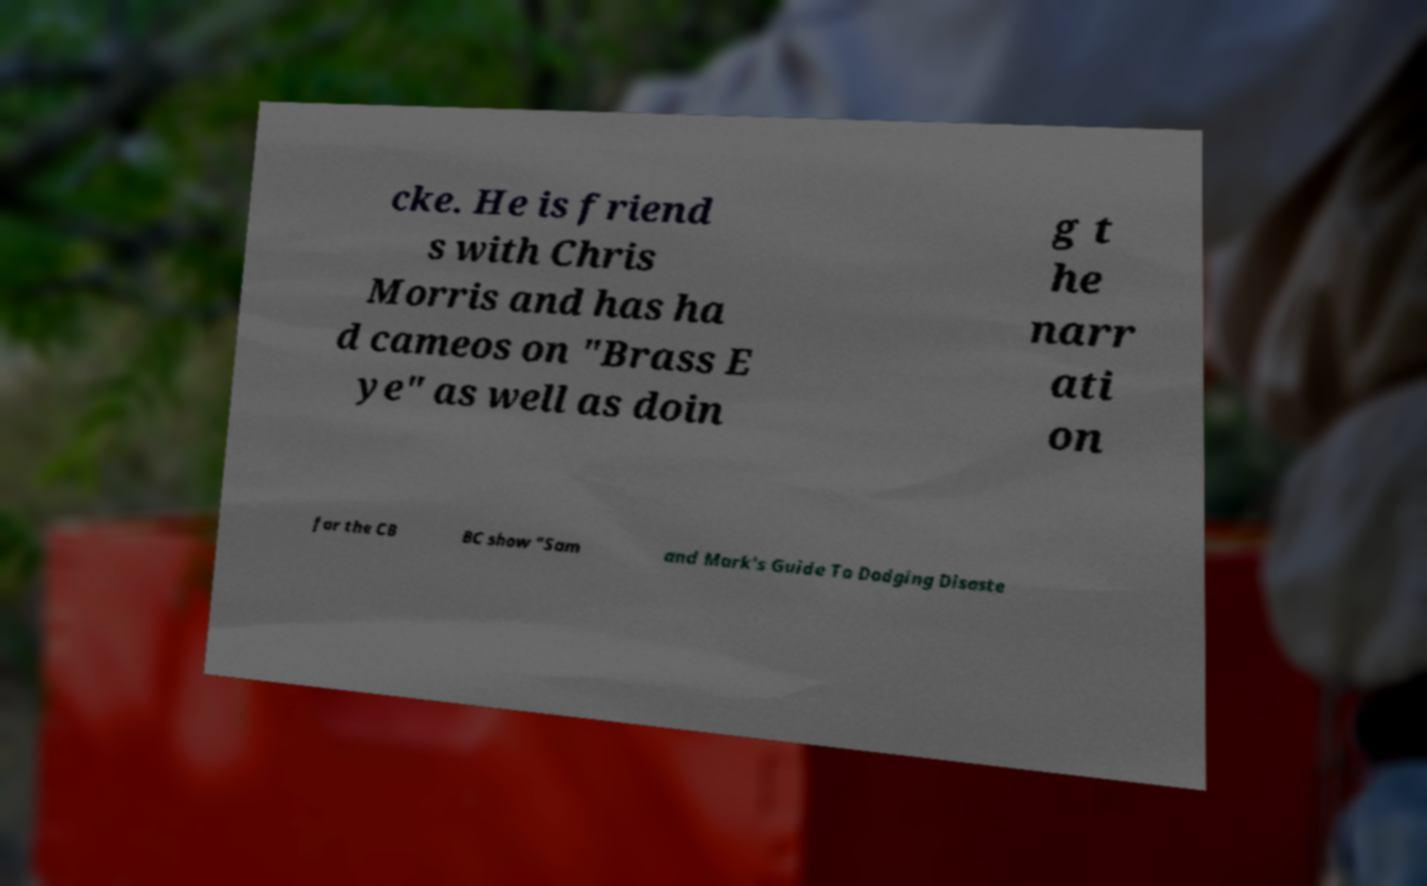Please read and relay the text visible in this image. What does it say? cke. He is friend s with Chris Morris and has ha d cameos on "Brass E ye" as well as doin g t he narr ati on for the CB BC show "Sam and Mark's Guide To Dodging Disaste 